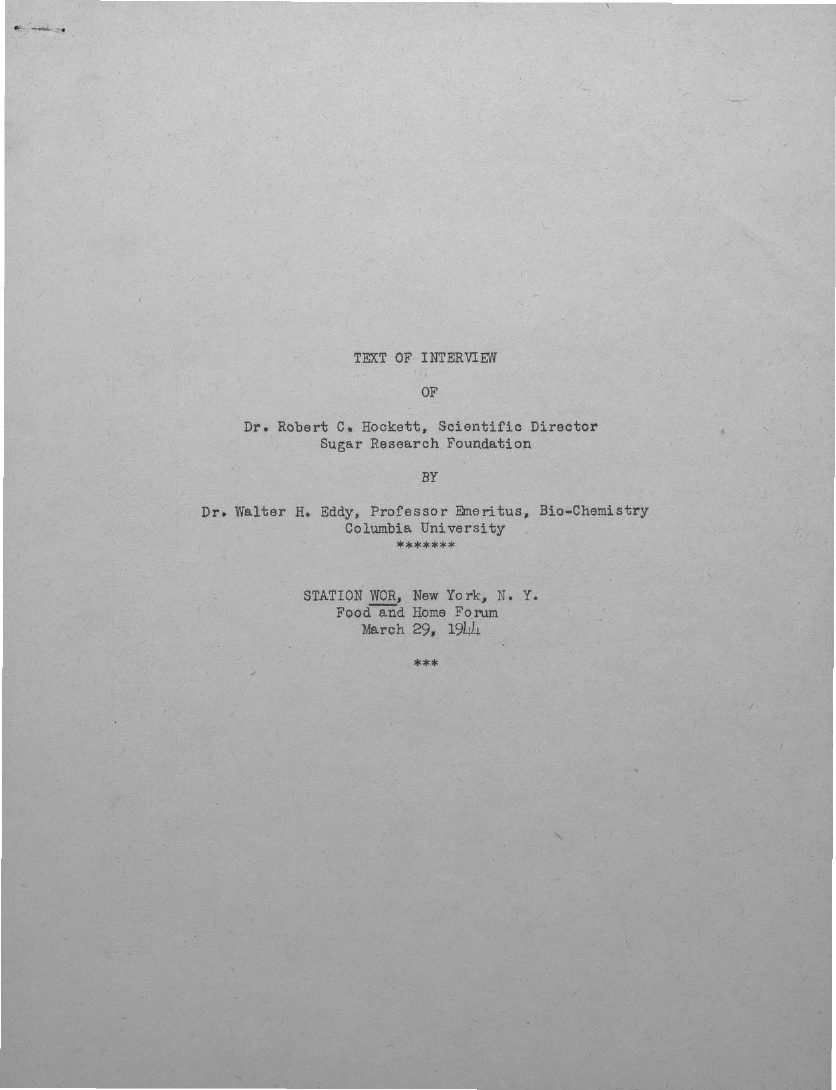Point out several critical features in this image. Dr. Walter H. Eddy is known as Professor Emeritus of Bio-Chemistry at Columbia University. Dr. Robert C. Hockett's designation is Scientific Director of the Sugar Research Foundation. 